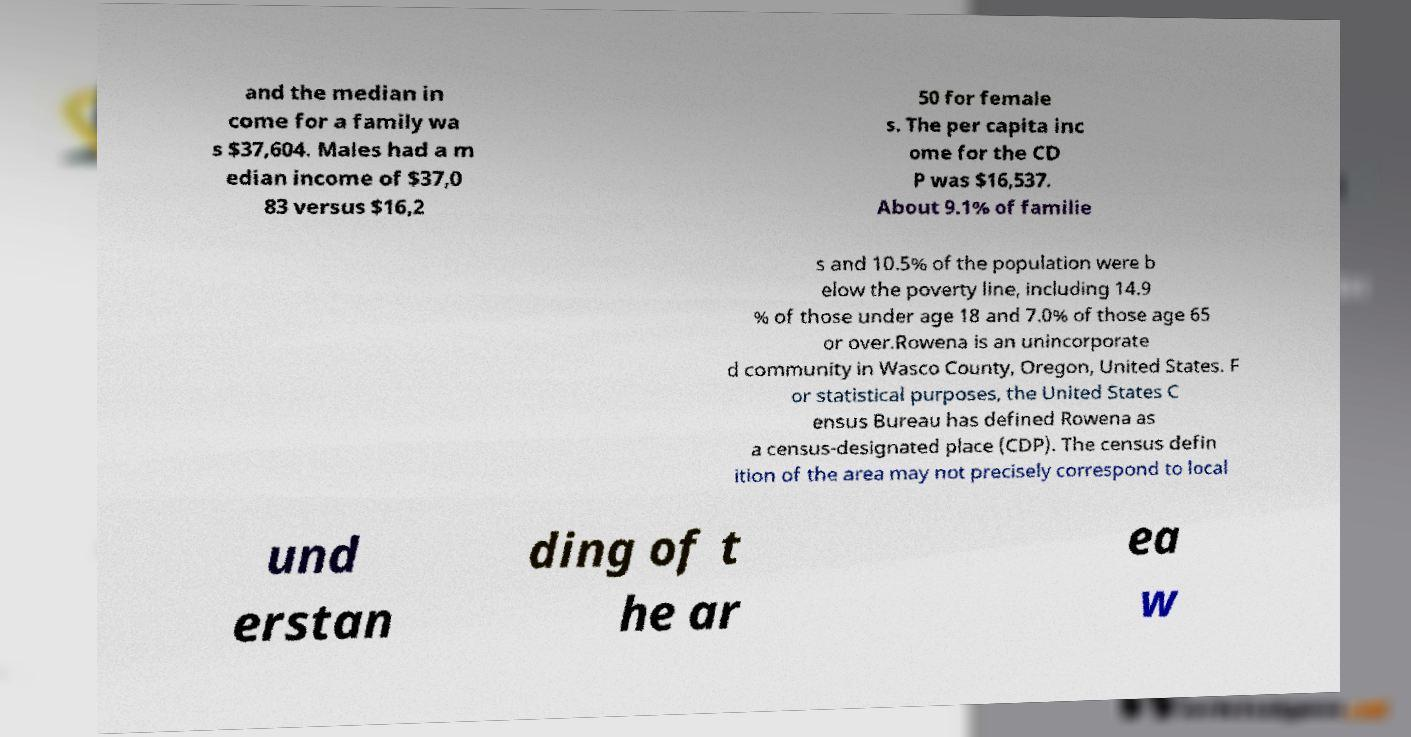Can you accurately transcribe the text from the provided image for me? and the median in come for a family wa s $37,604. Males had a m edian income of $37,0 83 versus $16,2 50 for female s. The per capita inc ome for the CD P was $16,537. About 9.1% of familie s and 10.5% of the population were b elow the poverty line, including 14.9 % of those under age 18 and 7.0% of those age 65 or over.Rowena is an unincorporate d community in Wasco County, Oregon, United States. F or statistical purposes, the United States C ensus Bureau has defined Rowena as a census-designated place (CDP). The census defin ition of the area may not precisely correspond to local und erstan ding of t he ar ea w 